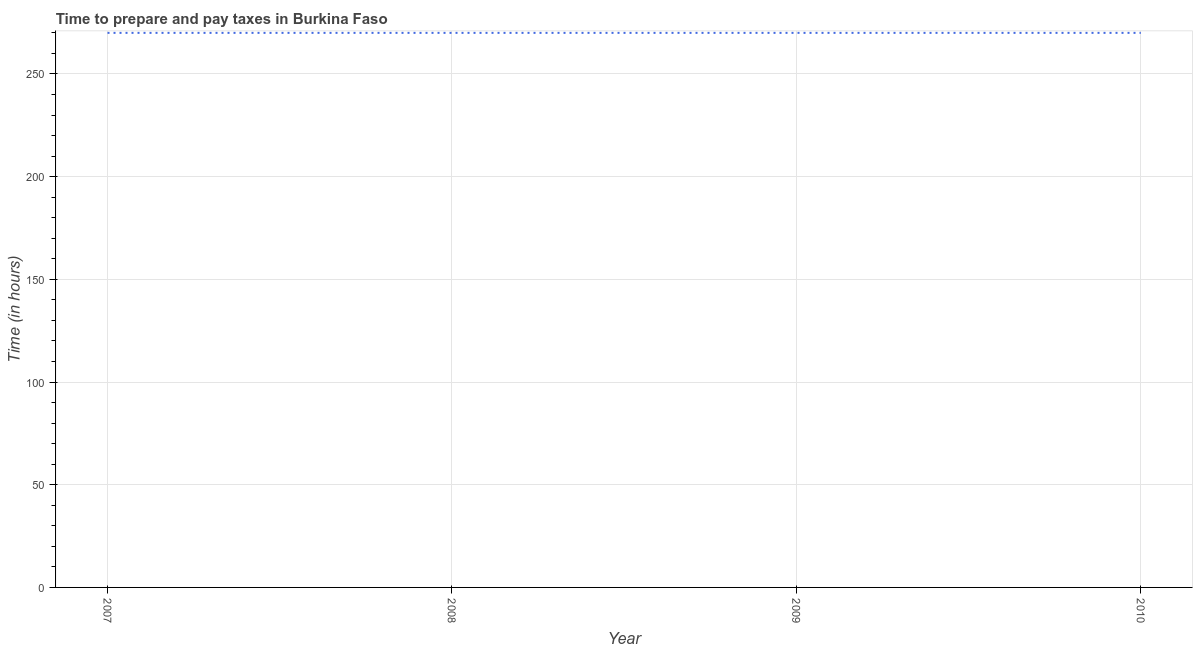What is the time to prepare and pay taxes in 2009?
Offer a terse response. 270. Across all years, what is the maximum time to prepare and pay taxes?
Provide a succinct answer. 270. Across all years, what is the minimum time to prepare and pay taxes?
Offer a terse response. 270. In which year was the time to prepare and pay taxes minimum?
Provide a short and direct response. 2007. What is the sum of the time to prepare and pay taxes?
Your answer should be compact. 1080. What is the difference between the time to prepare and pay taxes in 2008 and 2009?
Offer a terse response. 0. What is the average time to prepare and pay taxes per year?
Provide a short and direct response. 270. What is the median time to prepare and pay taxes?
Make the answer very short. 270. Is the time to prepare and pay taxes in 2008 less than that in 2009?
Ensure brevity in your answer.  No. Is the difference between the time to prepare and pay taxes in 2008 and 2010 greater than the difference between any two years?
Your answer should be compact. Yes. Is the sum of the time to prepare and pay taxes in 2007 and 2008 greater than the maximum time to prepare and pay taxes across all years?
Provide a short and direct response. Yes. What is the difference between the highest and the lowest time to prepare and pay taxes?
Make the answer very short. 0. Does the time to prepare and pay taxes monotonically increase over the years?
Your answer should be compact. No. How many years are there in the graph?
Your answer should be very brief. 4. What is the title of the graph?
Offer a terse response. Time to prepare and pay taxes in Burkina Faso. What is the label or title of the X-axis?
Your response must be concise. Year. What is the label or title of the Y-axis?
Make the answer very short. Time (in hours). What is the Time (in hours) in 2007?
Offer a terse response. 270. What is the Time (in hours) in 2008?
Offer a terse response. 270. What is the Time (in hours) in 2009?
Give a very brief answer. 270. What is the Time (in hours) in 2010?
Offer a very short reply. 270. What is the difference between the Time (in hours) in 2007 and 2008?
Keep it short and to the point. 0. What is the difference between the Time (in hours) in 2007 and 2009?
Offer a terse response. 0. What is the difference between the Time (in hours) in 2007 and 2010?
Provide a short and direct response. 0. What is the difference between the Time (in hours) in 2008 and 2010?
Your answer should be compact. 0. What is the difference between the Time (in hours) in 2009 and 2010?
Your answer should be compact. 0. What is the ratio of the Time (in hours) in 2007 to that in 2008?
Your answer should be compact. 1. What is the ratio of the Time (in hours) in 2007 to that in 2010?
Keep it short and to the point. 1. What is the ratio of the Time (in hours) in 2008 to that in 2009?
Your answer should be very brief. 1. 